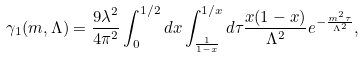<formula> <loc_0><loc_0><loc_500><loc_500>\gamma _ { 1 } ( m , \Lambda ) = \frac { 9 \lambda ^ { 2 } } { 4 \pi ^ { 2 } } \int _ { 0 } ^ { 1 / 2 } d x \int _ { \frac { 1 } { 1 - x } } ^ { 1 / x } d \tau \frac { x ( 1 - x ) } { \Lambda ^ { 2 } } e ^ { - \frac { m ^ { 2 } \tau } { \Lambda ^ { 2 } } } ,</formula> 